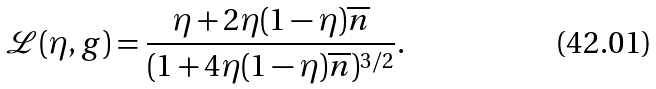<formula> <loc_0><loc_0><loc_500><loc_500>\mathcal { L } ( \eta , g ) = \frac { \eta + 2 \eta ( 1 - \eta ) \overline { n } } { ( 1 + 4 \eta ( 1 - \eta ) \overline { n } ) ^ { 3 / 2 } } .</formula> 